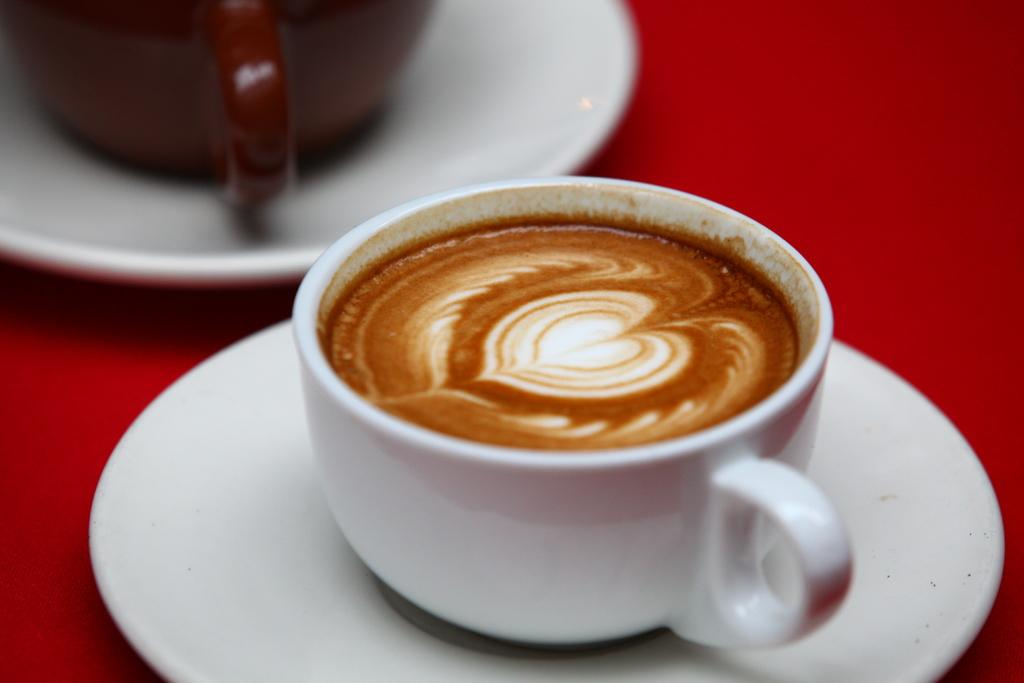What type of dishware is present in the image? There are saucers and coffee cups in the image. What surface are the saucers and coffee cups placed on? The saucers and coffee cups are on a red surface. What month is depicted on the saucers in the image? There is no indication of a specific month on the saucers in the image. How many ladybugs can be seen on the red surface in the image? There are no ladybugs present in the image. 